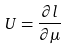Convert formula to latex. <formula><loc_0><loc_0><loc_500><loc_500>U = \frac { \partial l } { \partial \mu }</formula> 